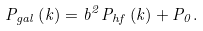Convert formula to latex. <formula><loc_0><loc_0><loc_500><loc_500>P _ { g a l } \left ( k \right ) = b ^ { 2 } P _ { h f } \left ( k \right ) + P _ { 0 } .</formula> 